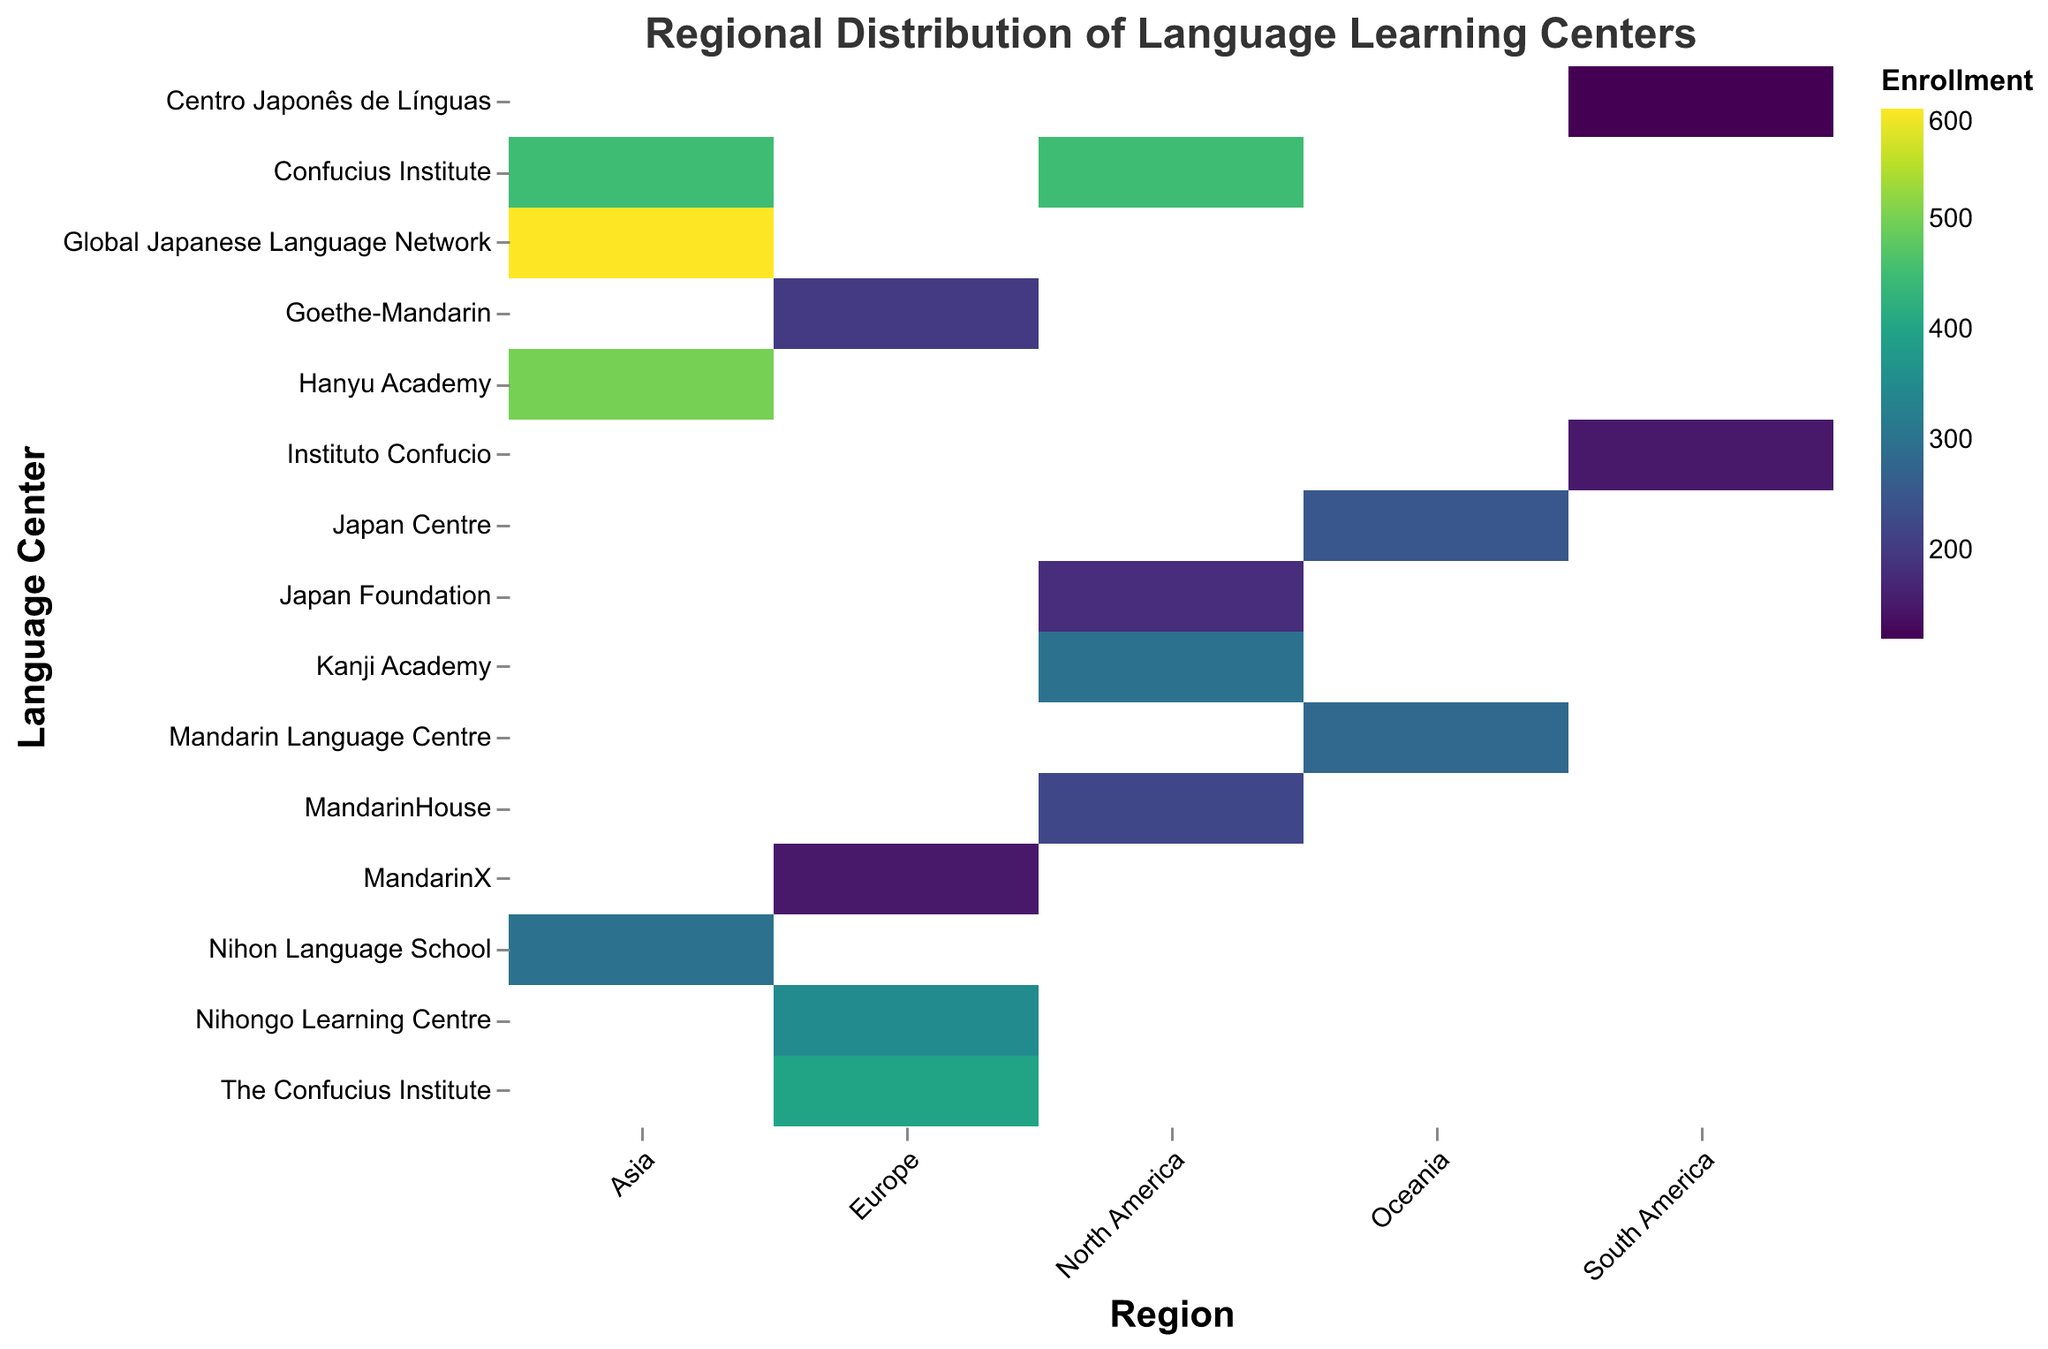What is the title of the heatmap? The title is typically located at the top of the chart and describes what the chart is about. Here, it is "Regional Distribution of Language Learning Centers".
Answer: Regional Distribution of Language Learning Centers Which language center has the highest enrollment number in Asia? Observe the heatmap and look for the language center in Asia with the darkest color, representing the highest enrollment number. The "Global Japanese Language Network" in Tokyo has the highest enrollment of 600.
Answer: Global Japanese Language Network What is the enrollment number for the Confucius Institute in Shanghai? Hover over or locate the cell corresponding to the Confucius Institute in Shanghai, within the Asia region. The tooltip or the color shading can help identify the enrollment numbers. It shows an enrollment of 450.
Answer: 450 Compare the enrollment numbers of the Confucius Institute between New York and Shanghai. Which one is higher? Check the color shading of the Confucius Institute in New York under North America and in Shanghai under Asia. The tooltip for New York shows 450 while Shanghai also shows 450. Both have the same enrollment numbers.
Answer: Same Which region has the language center with the lowest enrollment number? Look across the regions and find the lightest-colored cell that indicates the lowest enrollment. In the South America region, "Centro Japonês de Línguas" in Rio de Janeiro has the lowest number, 120.
Answer: South America What is the total enrollment number for all language centers in North America? Sum the enrollment numbers of all the language centers in North America: 450 (Confucius Institute) + 300 (Kanji Academy) + 220 (MandarinHouse) + 180 (Japan Foundation) = 1150.
Answer: 1150 Which language center in Europe has the lowest enrollment number? Look for the lightest-colored cell within the Europe region. The lightest color appears in the "MandarinX" center in Barcelona with 150 enrollments.
Answer: MandarinX Identify the region with the most diverse range of enrollment numbers. Consider how spread out the colors are within the region. Examine the range of colors for each region. Asia shows a wide spectrum from medium to very dark colors, indicating a diverse range of enrollment numbers from 300 to 600.
Answer: Asia How do the enrollment numbers for language centers in Oceania compare to those in South America? Check the enrollment numbers for Oceania: 280 (Mandarin Language Centre) + 250 (Japan Centre) = 530. In South America: 150 (Instituto Confucio) + 120 (Centro Japonês de Línguas) = 270. Oceania has higher enrollments.
Answer: Oceania has higher enrollments What is the average enrollment number across all the language centers listed? Add up all the enrollment numbers (450 + 300 + 220 + 180 + 200 + 350 + 400 + 150 + 500 + 600 + 450 + 300 + 280 + 250 + 150 + 120 = 4900) and divide by the number of language centers (16). 4900 / 16 = 306.25.
Answer: 306.25 